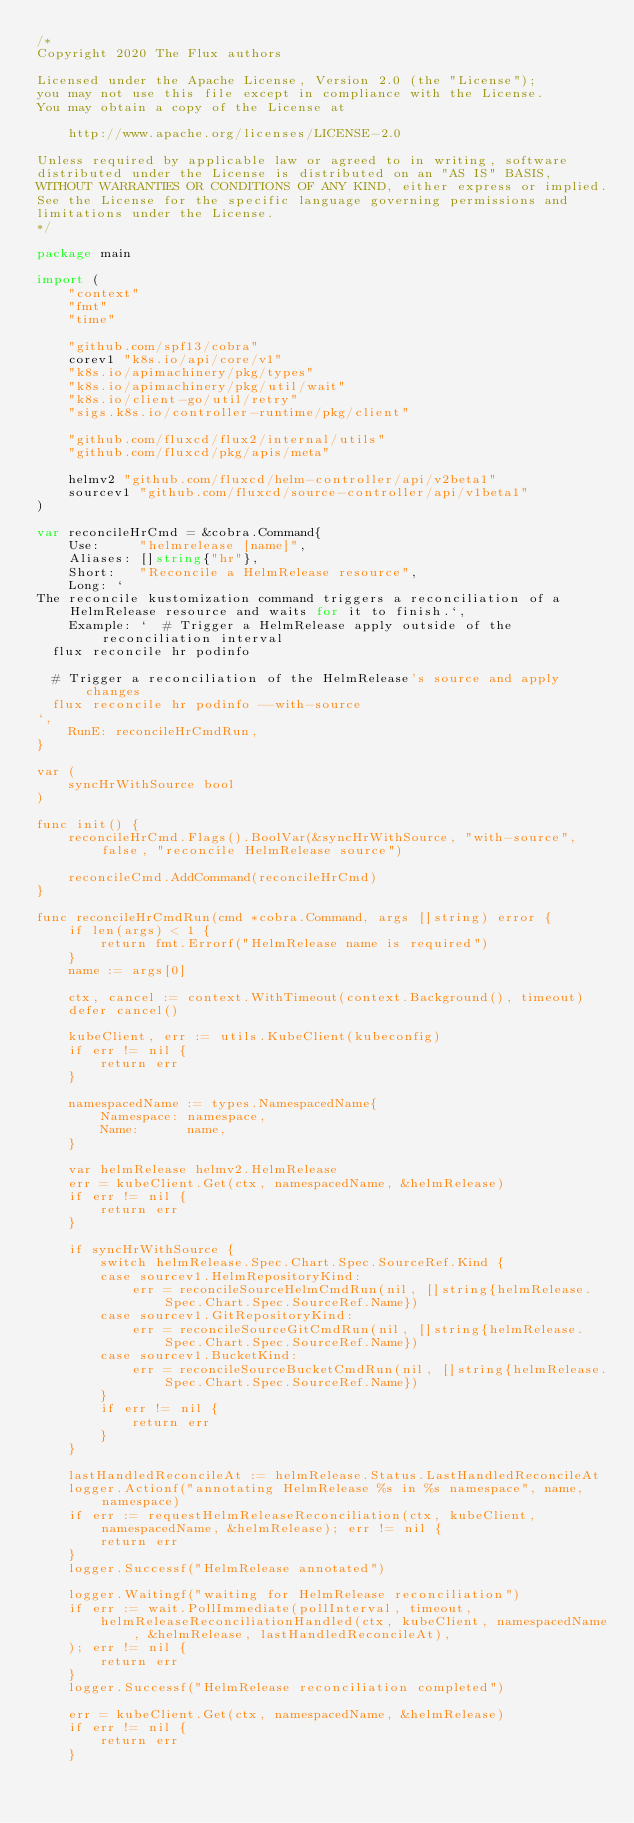Convert code to text. <code><loc_0><loc_0><loc_500><loc_500><_Go_>/*
Copyright 2020 The Flux authors

Licensed under the Apache License, Version 2.0 (the "License");
you may not use this file except in compliance with the License.
You may obtain a copy of the License at

    http://www.apache.org/licenses/LICENSE-2.0

Unless required by applicable law or agreed to in writing, software
distributed under the License is distributed on an "AS IS" BASIS,
WITHOUT WARRANTIES OR CONDITIONS OF ANY KIND, either express or implied.
See the License for the specific language governing permissions and
limitations under the License.
*/

package main

import (
	"context"
	"fmt"
	"time"

	"github.com/spf13/cobra"
	corev1 "k8s.io/api/core/v1"
	"k8s.io/apimachinery/pkg/types"
	"k8s.io/apimachinery/pkg/util/wait"
	"k8s.io/client-go/util/retry"
	"sigs.k8s.io/controller-runtime/pkg/client"

	"github.com/fluxcd/flux2/internal/utils"
	"github.com/fluxcd/pkg/apis/meta"

	helmv2 "github.com/fluxcd/helm-controller/api/v2beta1"
	sourcev1 "github.com/fluxcd/source-controller/api/v1beta1"
)

var reconcileHrCmd = &cobra.Command{
	Use:     "helmrelease [name]",
	Aliases: []string{"hr"},
	Short:   "Reconcile a HelmRelease resource",
	Long: `
The reconcile kustomization command triggers a reconciliation of a HelmRelease resource and waits for it to finish.`,
	Example: `  # Trigger a HelmRelease apply outside of the reconciliation interval
  flux reconcile hr podinfo

  # Trigger a reconciliation of the HelmRelease's source and apply changes
  flux reconcile hr podinfo --with-source
`,
	RunE: reconcileHrCmdRun,
}

var (
	syncHrWithSource bool
)

func init() {
	reconcileHrCmd.Flags().BoolVar(&syncHrWithSource, "with-source", false, "reconcile HelmRelease source")

	reconcileCmd.AddCommand(reconcileHrCmd)
}

func reconcileHrCmdRun(cmd *cobra.Command, args []string) error {
	if len(args) < 1 {
		return fmt.Errorf("HelmRelease name is required")
	}
	name := args[0]

	ctx, cancel := context.WithTimeout(context.Background(), timeout)
	defer cancel()

	kubeClient, err := utils.KubeClient(kubeconfig)
	if err != nil {
		return err
	}

	namespacedName := types.NamespacedName{
		Namespace: namespace,
		Name:      name,
	}

	var helmRelease helmv2.HelmRelease
	err = kubeClient.Get(ctx, namespacedName, &helmRelease)
	if err != nil {
		return err
	}

	if syncHrWithSource {
		switch helmRelease.Spec.Chart.Spec.SourceRef.Kind {
		case sourcev1.HelmRepositoryKind:
			err = reconcileSourceHelmCmdRun(nil, []string{helmRelease.Spec.Chart.Spec.SourceRef.Name})
		case sourcev1.GitRepositoryKind:
			err = reconcileSourceGitCmdRun(nil, []string{helmRelease.Spec.Chart.Spec.SourceRef.Name})
		case sourcev1.BucketKind:
			err = reconcileSourceBucketCmdRun(nil, []string{helmRelease.Spec.Chart.Spec.SourceRef.Name})
		}
		if err != nil {
			return err
		}
	}

	lastHandledReconcileAt := helmRelease.Status.LastHandledReconcileAt
	logger.Actionf("annotating HelmRelease %s in %s namespace", name, namespace)
	if err := requestHelmReleaseReconciliation(ctx, kubeClient, namespacedName, &helmRelease); err != nil {
		return err
	}
	logger.Successf("HelmRelease annotated")

	logger.Waitingf("waiting for HelmRelease reconciliation")
	if err := wait.PollImmediate(pollInterval, timeout,
		helmReleaseReconciliationHandled(ctx, kubeClient, namespacedName, &helmRelease, lastHandledReconcileAt),
	); err != nil {
		return err
	}
	logger.Successf("HelmRelease reconciliation completed")

	err = kubeClient.Get(ctx, namespacedName, &helmRelease)
	if err != nil {
		return err
	}</code> 